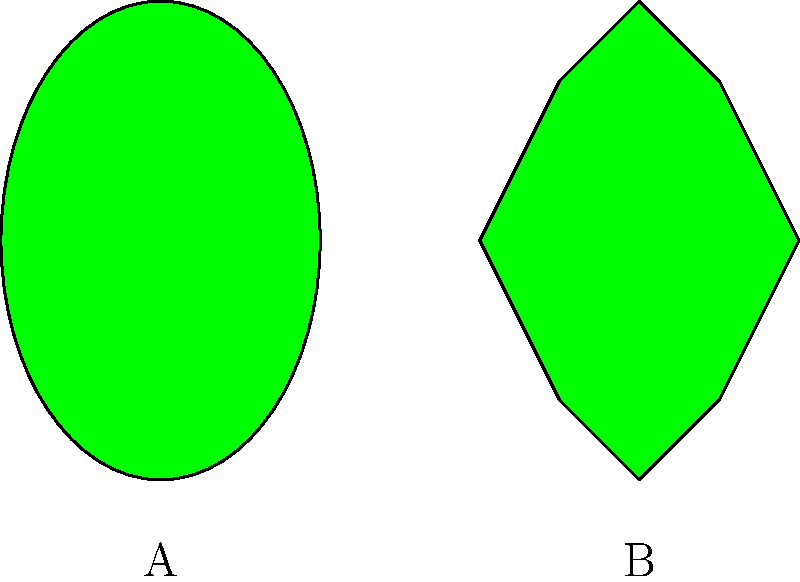As a school committee member in Lexington, Massachusetts, you're reviewing a proposed machine learning project for classifying tree species based on leaf shape. Which of the following leaf shapes is more likely to belong to an oak tree, considering the typical characteristics of oak leaves? To answer this question, let's consider the characteristics of oak leaves and compare them to the leaf shapes shown in the image:

1. Oak leaf characteristics:
   - Often have lobed edges
   - Typically asymmetrical
   - Usually longer than they are wide

2. Analyzing the leaf shapes in the image:
   - Leaf A:
     - Smooth, elliptical shape
     - No lobes or indentations
     - Symmetrical

   - Leaf B:
     - Lobed edges with clear indentations
     - Slightly asymmetrical
     - Longer than it is wide

3. Comparing the leaves to oak leaf characteristics:
   - Leaf A does not match the typical oak leaf features
   - Leaf B closely resembles the common characteristics of oak leaves

4. Machine learning implications:
   - A classifier would likely be trained to recognize the lobed structure as a key feature of oak leaves
   - The smooth elliptical shape of Leaf A is more typical of other tree species

Based on these observations, Leaf B is more likely to belong to an oak tree and would be a better example for training a machine learning model to recognize oak leaves.
Answer: Leaf B 